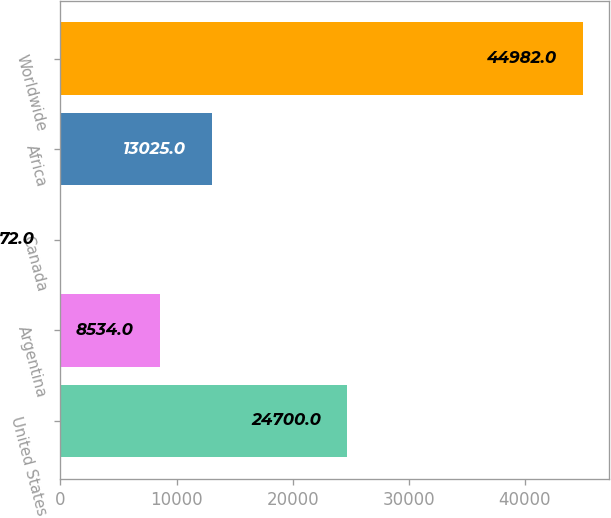<chart> <loc_0><loc_0><loc_500><loc_500><bar_chart><fcel>United States<fcel>Argentina<fcel>Canada<fcel>Africa<fcel>Worldwide<nl><fcel>24700<fcel>8534<fcel>72<fcel>13025<fcel>44982<nl></chart> 